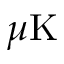Convert formula to latex. <formula><loc_0><loc_0><loc_500><loc_500>\mu K</formula> 